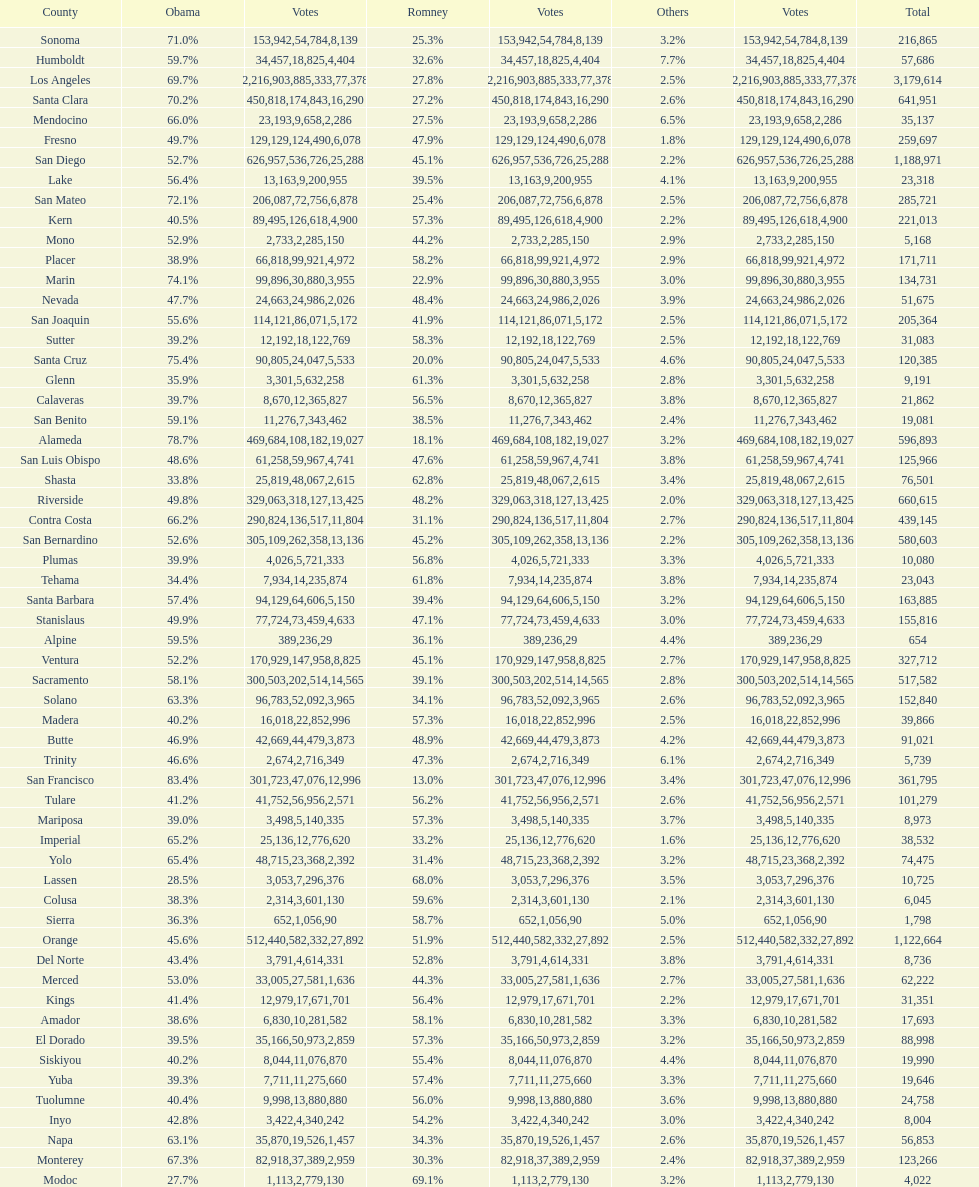Which county had the most total votes? Los Angeles. 